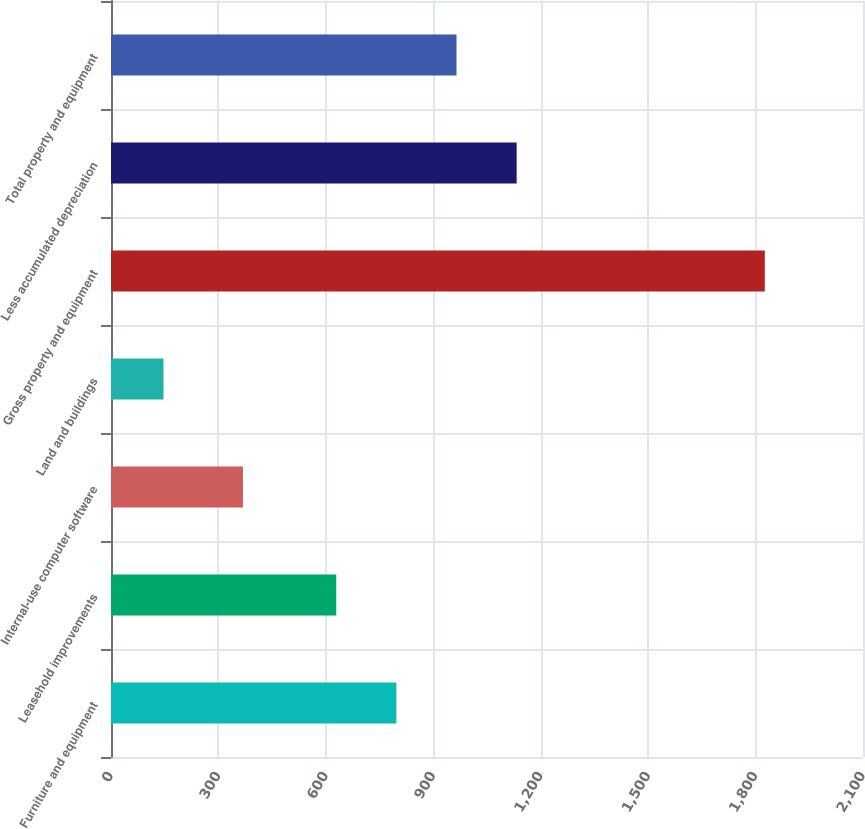<chart> <loc_0><loc_0><loc_500><loc_500><bar_chart><fcel>Furniture and equipment<fcel>Leasehold improvements<fcel>Internal-use computer software<fcel>Land and buildings<fcel>Gross property and equipment<fcel>Less accumulated depreciation<fcel>Total property and equipment<nl><fcel>796.92<fcel>629<fcel>368.5<fcel>146.6<fcel>1825.8<fcel>1132.76<fcel>964.84<nl></chart> 